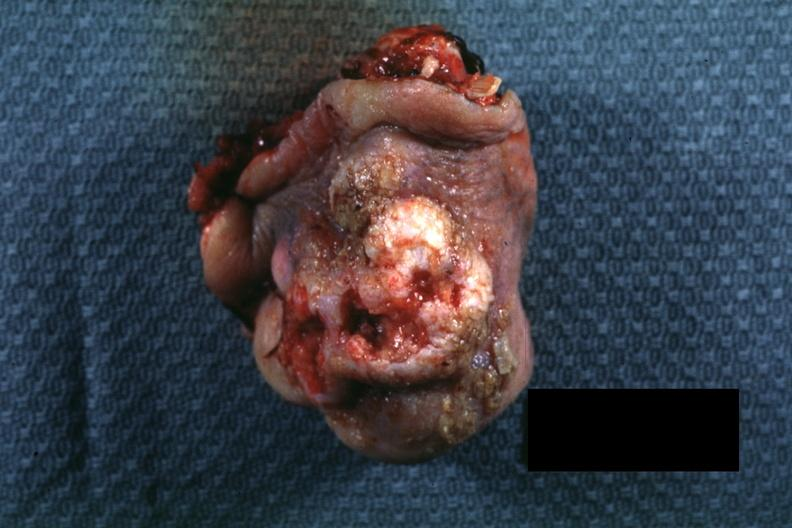what does this image show?
Answer the question using a single word or phrase. Portion of nose typical exophytic lesion with heaped-up margins and central ulceration 